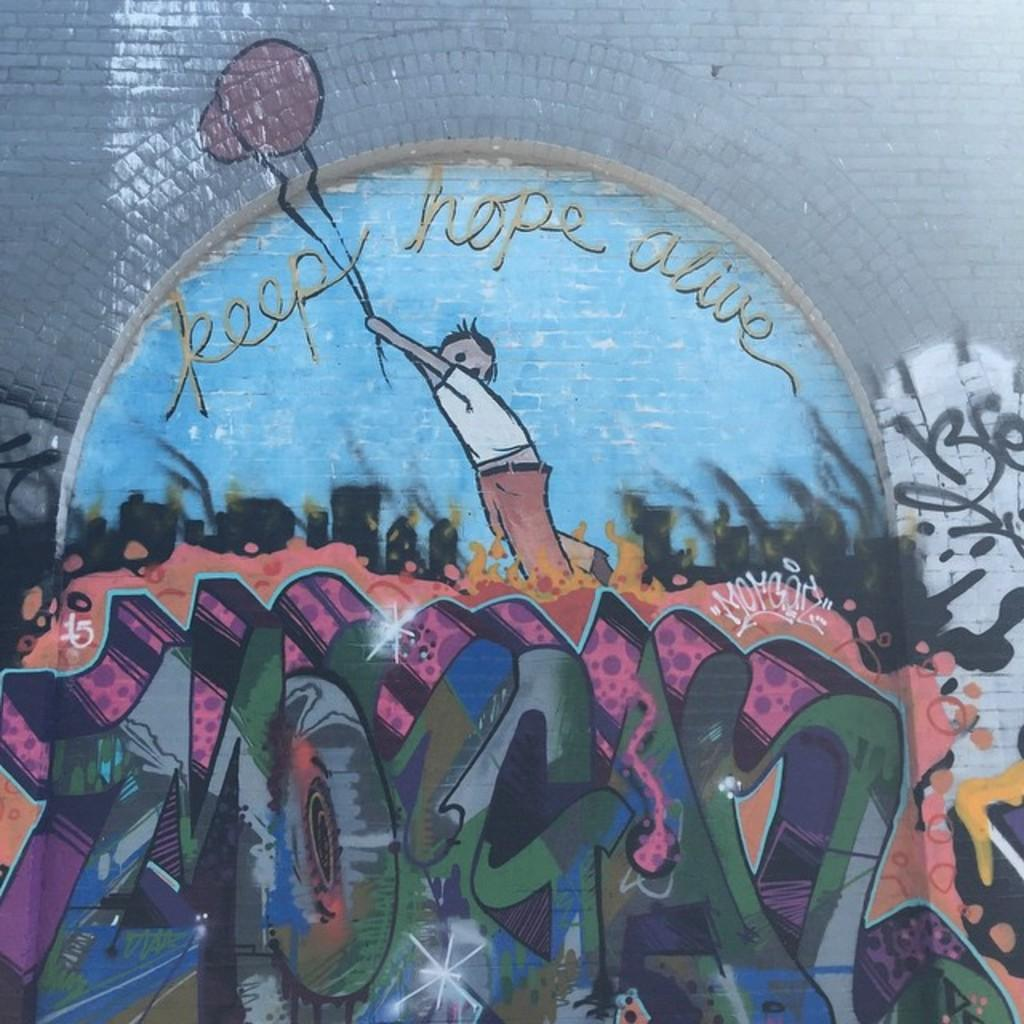What type of artwork is depicted in the image? The image appears to be a painting. What is the main subject of the painting? There is a boy in the middle of the painting. What is the boy holding in the painting? The boy is holding balloons. What message or phrase is written in the painting? The phrase "Keep Hope Alive" is written in the painting. What type of hammer is the boy using to hit the farm in the painting? There is no hammer or farm present in the painting. The boy is holding balloons and the phrase "Keep Hope Alive" is written in the painting. 